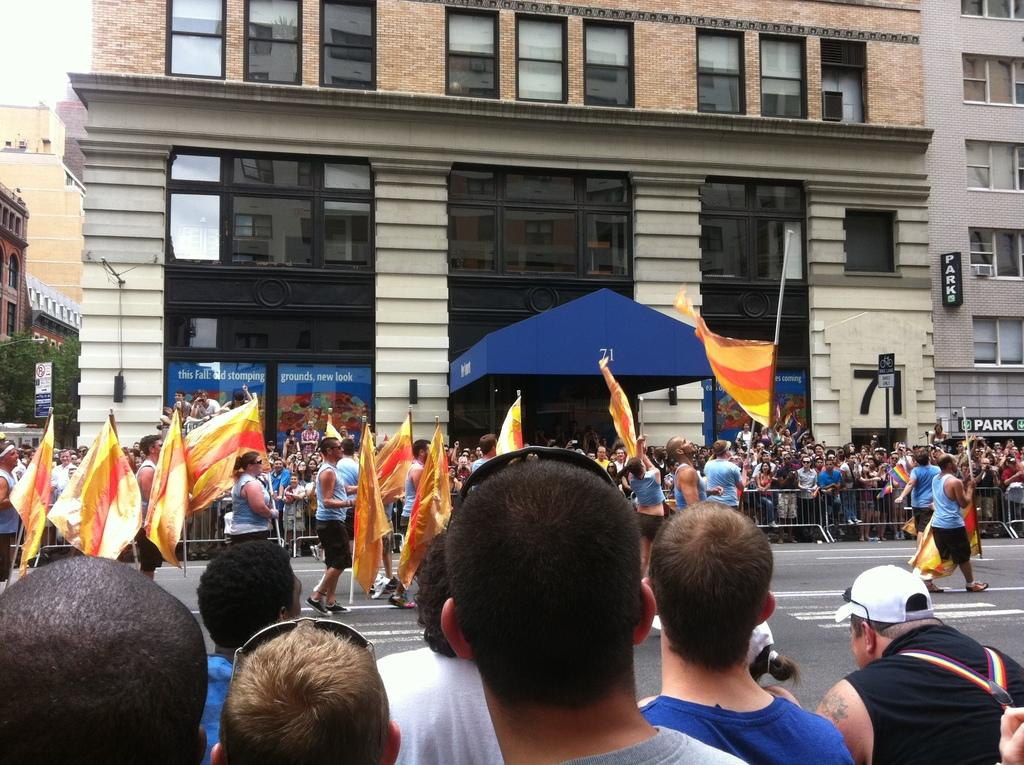What can be seen in the image involving people? There are people standing in the image, and some of them are holding flags and walking. What type of structures are present in the image? There are buildings in the image. What feature can be observed on the buildings? There are windows on the buildings. What type of coast can be seen in the image? There is no coast present in the image. How many apples are being held by the people in the image? There are no apples visible in the image; people are holding flags instead. 